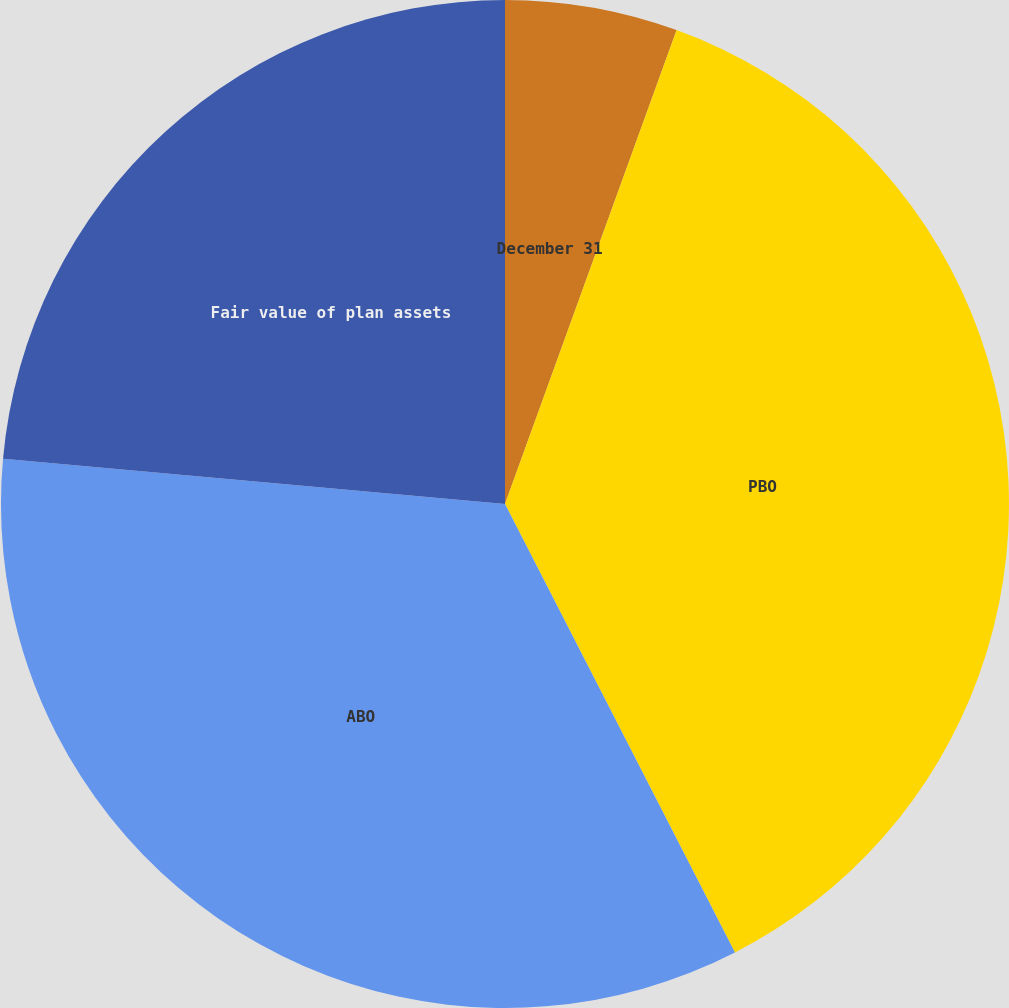<chart> <loc_0><loc_0><loc_500><loc_500><pie_chart><fcel>December 31<fcel>PBO<fcel>ABO<fcel>Fair value of plan assets<nl><fcel>5.53%<fcel>36.93%<fcel>33.97%<fcel>23.57%<nl></chart> 